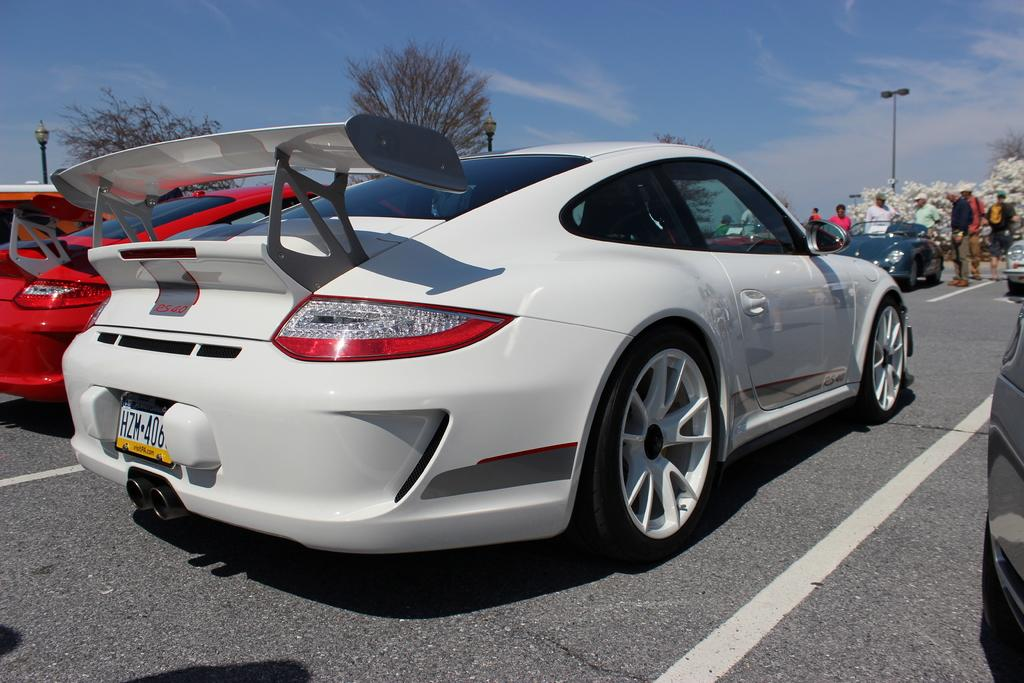What is happening on the road in the image? There are vehicles on the road in the image. What can be seen in the background of the image? There are trees visible in the image. What are the people near the car doing in the image? There are people near a car in the image, but their specific actions are not clear. What is visible in the sky in the image? Clouds are present in the sky in the image. What type of fork can be seen in the image? There is no fork present in the image. Is there an alley visible in the image? There is no alley visible in the image; only a road and trees are present. 